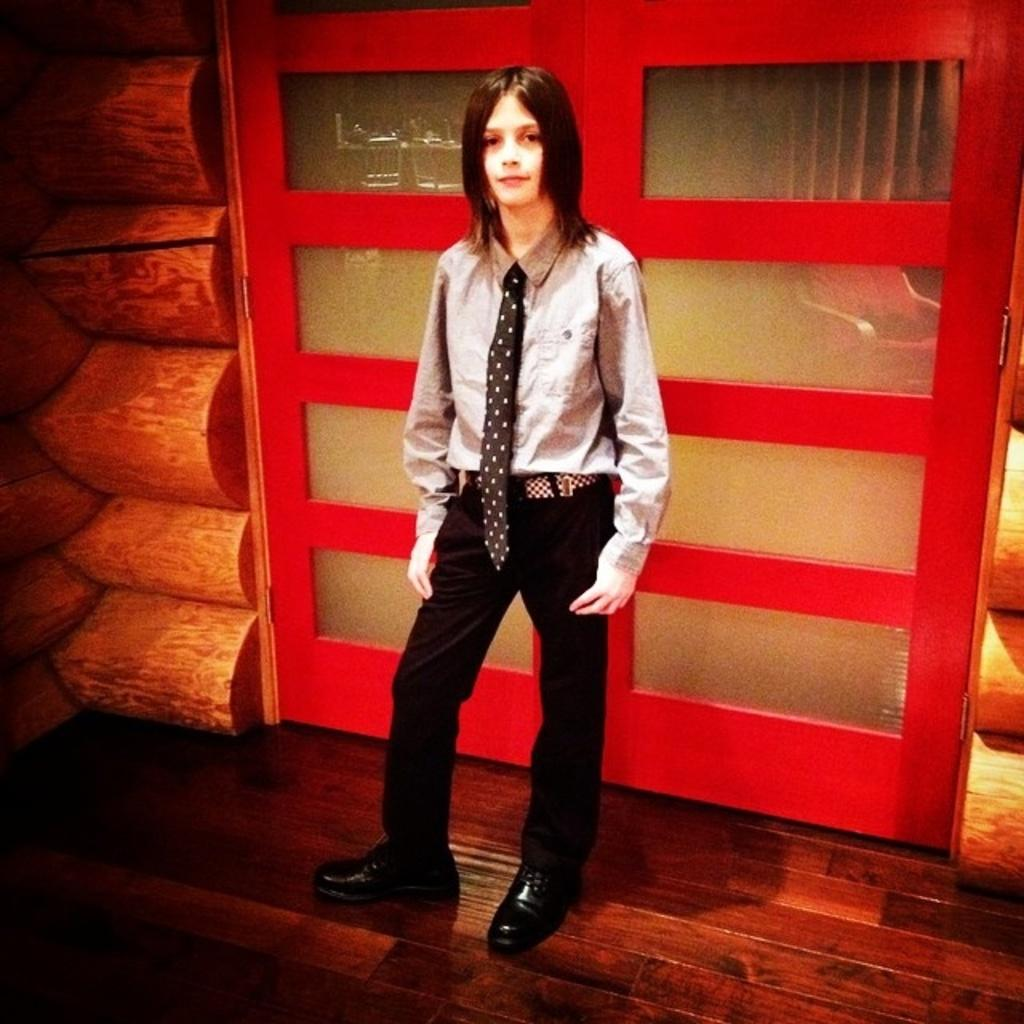What is the main subject of the image? There is a person in the image. What is the person wearing on their upper body? The person is wearing a shirt. What type of trousers is the person wearing? The person is wearing black trousers. What type of accessory is the person wearing around their neck? The person is wearing a tie. What material can be seen in the image? There is a wooden surface and a wooden wall in the image. What color is the door in the image? There is a red door in the image. What type of waste or error is depicted in the image? There is no waste or error depicted in the image; it features a person wearing a shirt, black trousers, and a tie, along with a wooden surface, wooden wall, and red door. Is there a veil present in the image? No, there is no veil present in the image. 